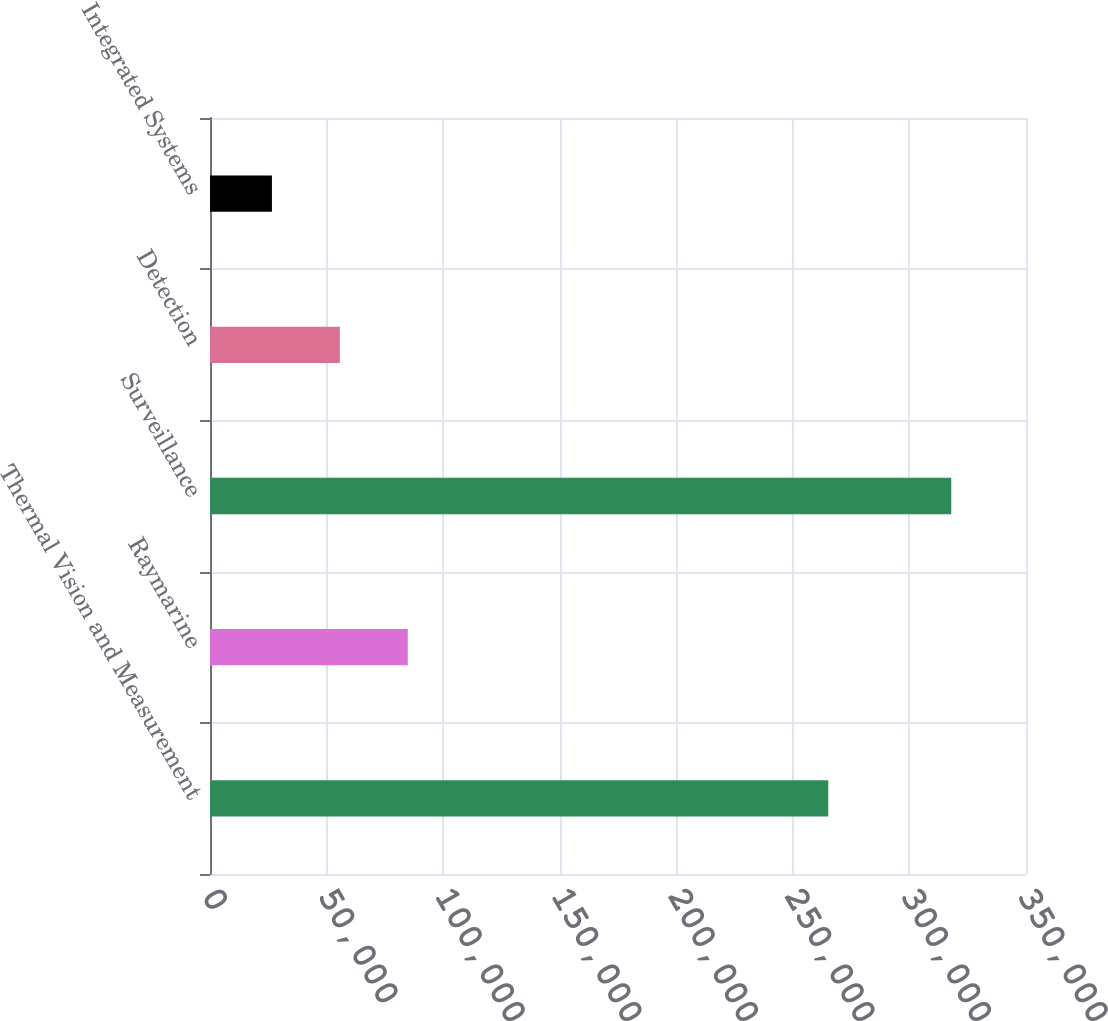Convert chart to OTSL. <chart><loc_0><loc_0><loc_500><loc_500><bar_chart><fcel>Thermal Vision and Measurement<fcel>Raymarine<fcel>Surveillance<fcel>Detection<fcel>Integrated Systems<nl><fcel>265197<fcel>84836<fcel>317944<fcel>55697.5<fcel>26559<nl></chart> 